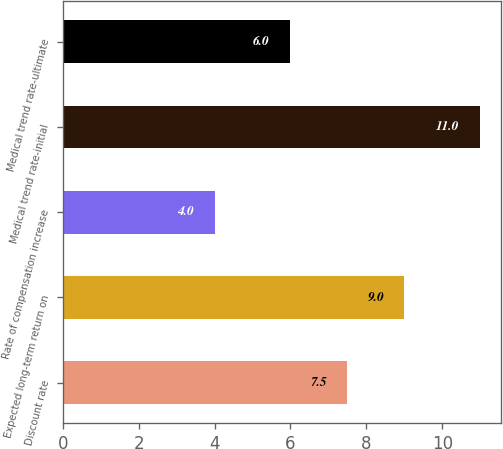Convert chart to OTSL. <chart><loc_0><loc_0><loc_500><loc_500><bar_chart><fcel>Discount rate<fcel>Expected long-term return on<fcel>Rate of compensation increase<fcel>Medical trend rate-initial<fcel>Medical trend rate-ultimate<nl><fcel>7.5<fcel>9<fcel>4<fcel>11<fcel>6<nl></chart> 